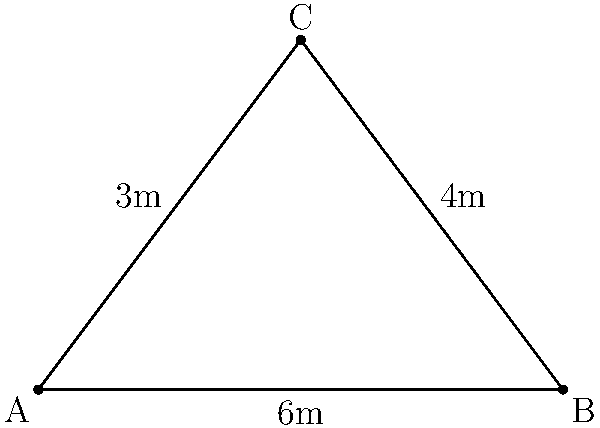As a point guard, you need to make a bounce pass to your teammate. The pass will travel from point A to point C, bouncing once at point B. If the distance from A to B is 6 meters, and the height of the pass at point C is 4 meters, what is the total length of the bounce pass (AC) in meters? To solve this problem, we can use the Pythagorean theorem. Let's break it down step-by-step:

1) We are given a right triangle ABC, where:
   - AB = 6 meters (base)
   - BC = 4 meters (height)
   - AC is the hypotenuse (the length we need to find)

2) The Pythagorean theorem states that in a right triangle:
   $a^2 + b^2 = c^2$, where c is the hypotenuse

3) Let's plug in our known values:
   $AC^2 = AB^2 + BC^2$

4) Substitute the values:
   $AC^2 = 6^2 + 4^2$

5) Calculate:
   $AC^2 = 36 + 16 = 52$

6) To find AC, we need to take the square root of both sides:
   $AC = \sqrt{52}$

7) Simplify:
   $AC = 2\sqrt{13}$ meters

This length represents the direct path of the bounce pass from point A to point C.
Answer: $2\sqrt{13}$ meters 